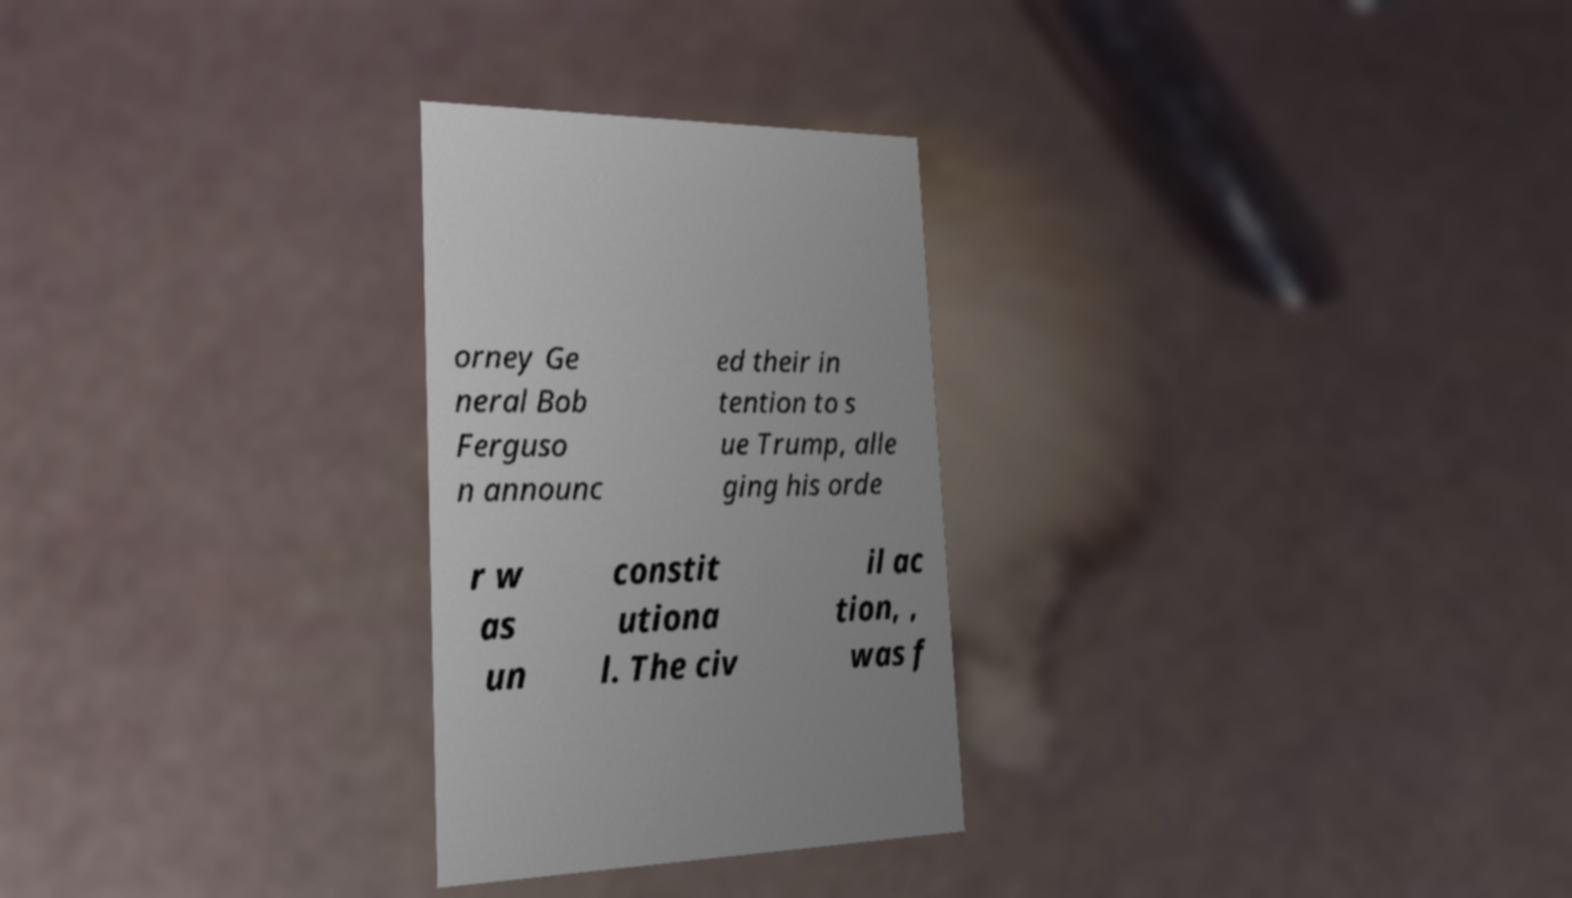Can you read and provide the text displayed in the image?This photo seems to have some interesting text. Can you extract and type it out for me? orney Ge neral Bob Ferguso n announc ed their in tention to s ue Trump, alle ging his orde r w as un constit utiona l. The civ il ac tion, , was f 